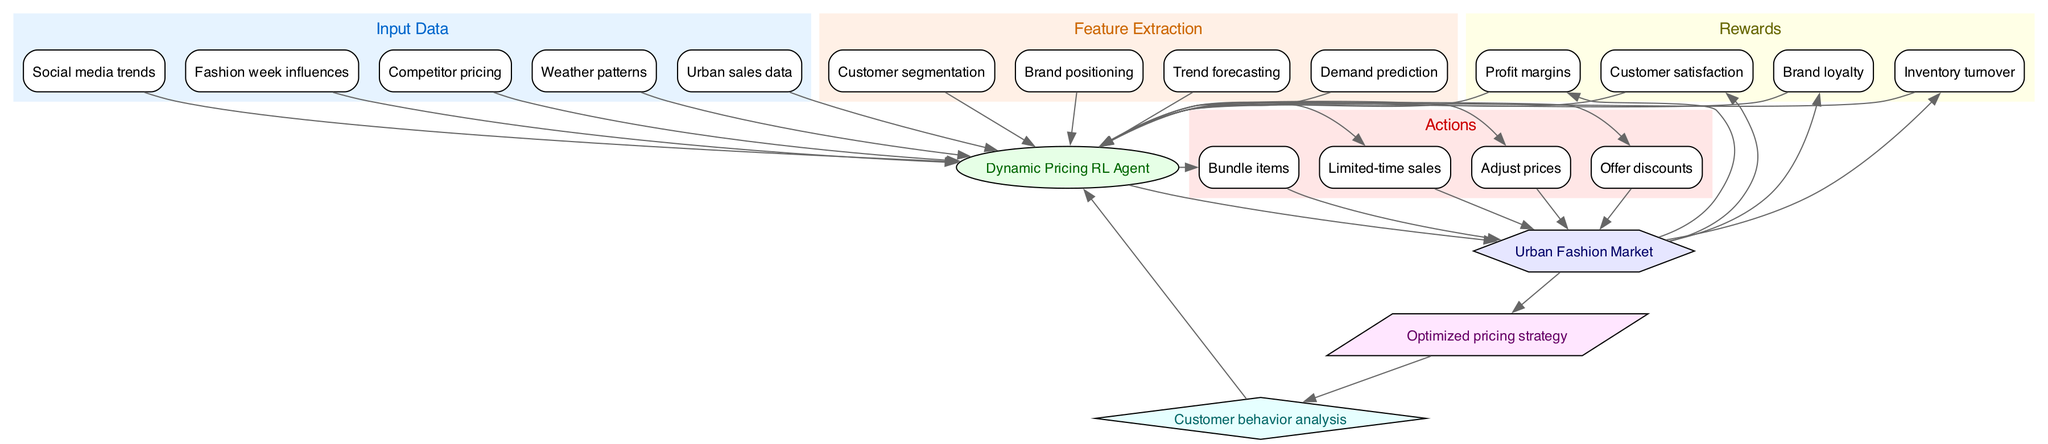What is the model in this diagram? The model node is labeled "Dynamic Pricing RL Agent," which directly corresponds to the node representing the algorithm in the system.
Answer: Dynamic Pricing RL Agent How many input data points are there? The input data subgraph contains five nodes: Urban sales data, Social media trends, Fashion week influences, Competitor pricing, and Weather patterns. Counting these gives us five input data points.
Answer: 5 What are the actions available to the model? The actions subgraph includes four nodes: Adjust prices, Offer discounts, Bundle items, and Limited-time sales. Thus, the model has four defined actions it can take.
Answer: Adjust prices, Offer discounts, Bundle items, Limited-time sales Which element acts as the environment in this diagram? The environment node is specifically labeled as "Urban Fashion Market," which indicates the context within which the model operates.
Answer: Urban Fashion Market What is the output of the system? The output node is labeled "Optimized pricing strategy," indicating what the model produces after processing the inputs and decisions.
Answer: Optimized pricing strategy How does customer behavior analysis interact with the model? The customer behavior analysis node is part of the feedback loop, where it is connected back to the model. This signifies that the insights gained from customer behavior impact future decision-making of the model.
Answer: Feedback loop How many rewards are defined in this system? The rewards subgraph contains four nodes: Profit margins, Customer satisfaction, Brand loyalty, and Inventory turnover. Counting these gives us four defined rewards.
Answer: 4 What influences the feature extraction process? The feature extraction process receives input from five categories: Urban sales data, Social media trends, Fashion week influences, Competitor pricing, and Weather patterns, which assist in developing comprehensive insights for the model.
Answer: Urban sales data, Social media trends, Fashion week influences, Competitor pricing, Weather patterns Which node depicts a decision-making entity? The model node, "Dynamic Pricing RL Agent," represents the decision-making entity as it is where actions are determined based on the inputs and environment.
Answer: Dynamic Pricing RL Agent 